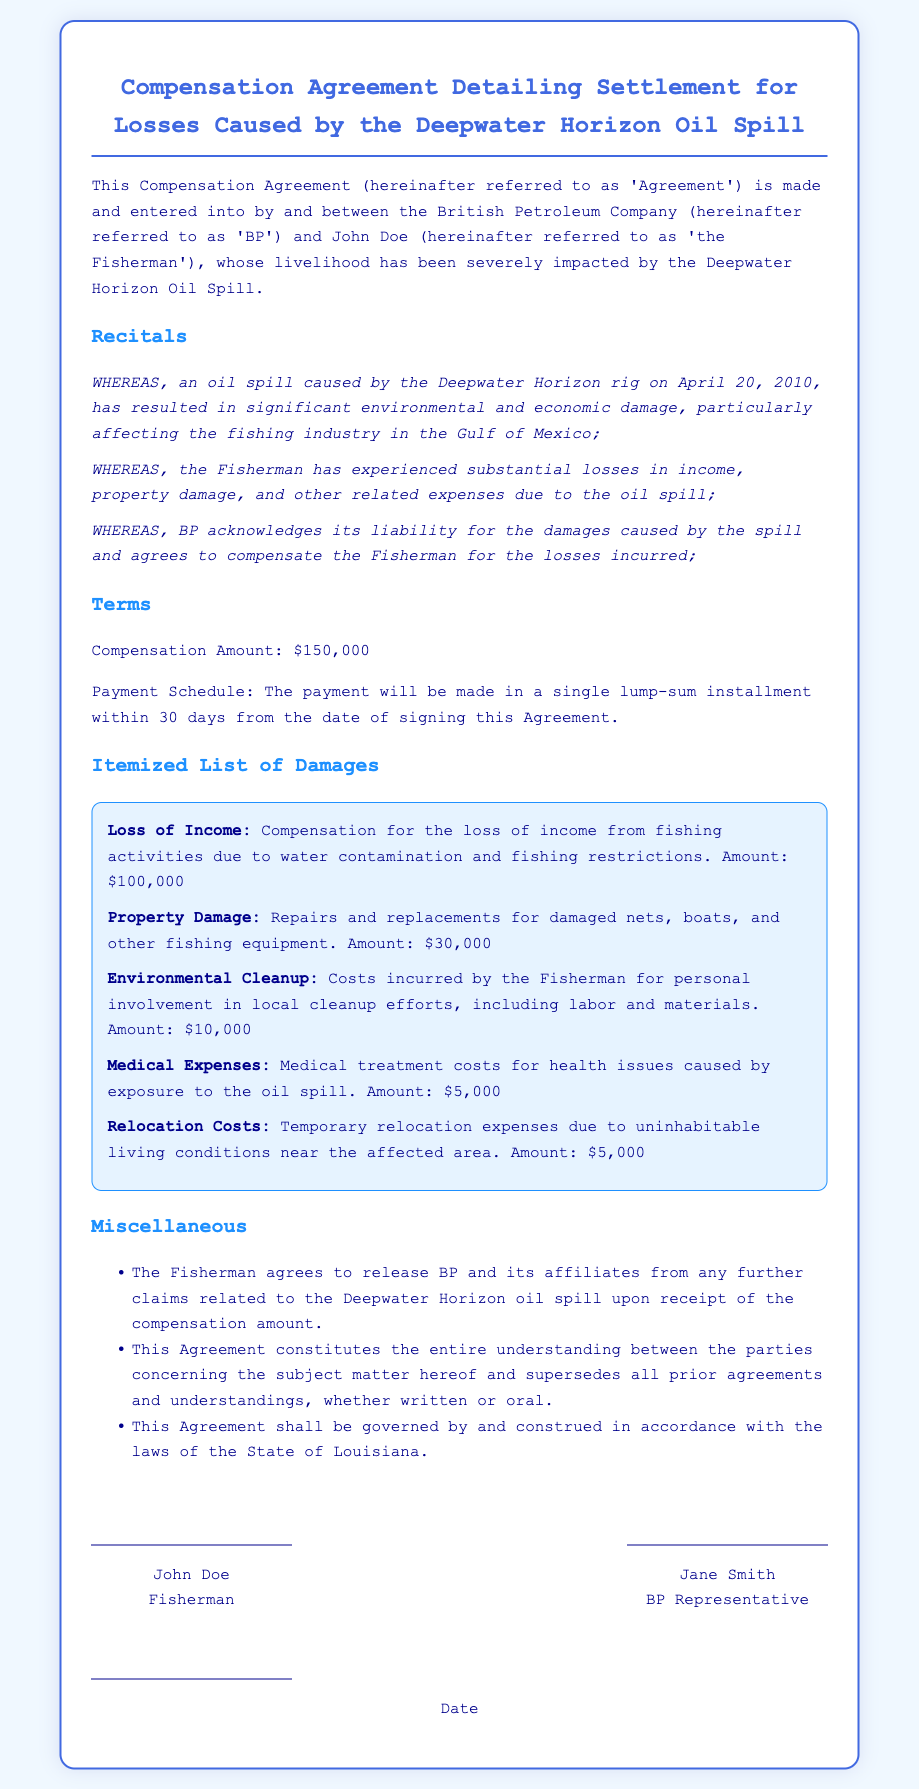what is the total compensation amount? The total compensation amount is explicitly stated in the document.
Answer: $150,000 who is the party responsible for the oil spill? The document names the company responsible for the spill as BP.
Answer: BP what date did the oil spill occur? The document specifies the date of the oil spill event in the recitals section.
Answer: April 20, 2010 how much compensation is allocated for loss of income? The itemized list details a specific compensation amount for loss of income.
Answer: $100,000 what is the payment schedule mentioned in the document? The document outlines the timing for when the compensation will be paid.
Answer: single lump-sum installment within 30 days what are the environmental cleanup costs? The itemized list of damages provides a distinct amount for environmental cleanup.
Answer: $10,000 who is the fisherman named in the agreement? The document identifies the individual receiving the compensation.
Answer: John Doe what legal jurisdiction governs this agreement? The agreement mentions which state's laws will govern the document.
Answer: State of Louisiana what is the medical expenses compensation amount? The document specifies a distinct amount to cover medical expenses incurred.
Answer: $5,000 